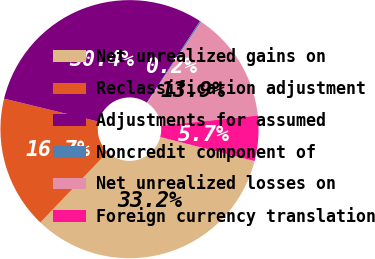Convert chart. <chart><loc_0><loc_0><loc_500><loc_500><pie_chart><fcel>Net unrealized gains on<fcel>Reclassification adjustment<fcel>Adjustments for assumed<fcel>Noncredit component of<fcel>Net unrealized losses on<fcel>Foreign currency translation<nl><fcel>33.16%<fcel>16.67%<fcel>30.41%<fcel>0.18%<fcel>13.92%<fcel>5.67%<nl></chart> 